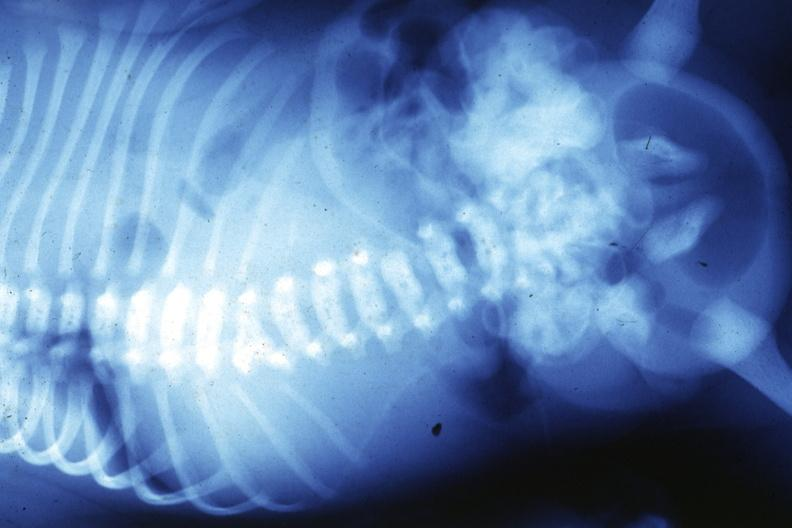what is present?
Answer the question using a single word or phrase. Joints 